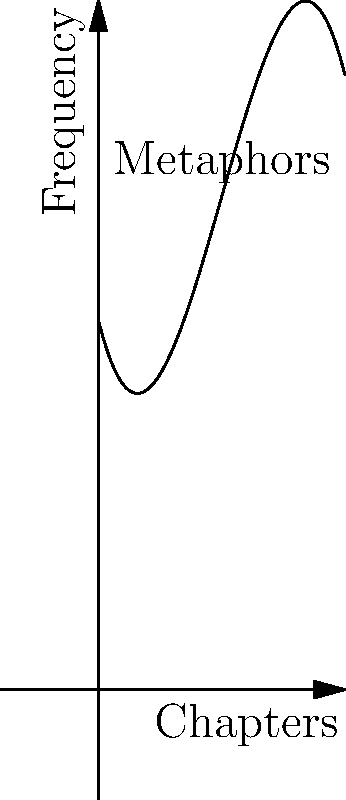The polynomial function $f(x) = -0.1x^3 + 1.5x^2 - 4x + 15$ represents the frequency of metaphors used throughout a novel, where $x$ is the chapter number. At which chapter does the use of metaphors peak, and what literary significance might this have? To find the peak of the function, we need to follow these steps:

1) Find the derivative of the function:
   $f'(x) = -0.3x^2 + 3x - 4$

2) Set the derivative to zero and solve for x:
   $-0.3x^2 + 3x - 4 = 0$
   
3) This is a quadratic equation. Using the quadratic formula:
   $x = \frac{-b \pm \sqrt{b^2 - 4ac}}{2a}$
   
   Where $a = -0.3$, $b = 3$, and $c = -4$
   
4) Solving:
   $x = \frac{-3 \pm \sqrt{9 - 4(-0.3)(-4)}}{2(-0.3)}$
   $x = \frac{-3 \pm \sqrt{9 - 4.8}}{-0.6}$
   $x = \frac{-3 \pm \sqrt{4.2}}{-0.6}$
   
5) This gives us two solutions:
   $x_1 \approx 7.37$ and $x_2 \approx 2.63$

6) The larger value, 7.37, represents the peak as it's a maximum point.

Literary significance: The peak occurring around chapter 7 might indicate a climax or turning point in the narrative where metaphorical language is most intensely employed to convey complex ideas or emotions.
Answer: Chapter 7; possible narrative climax 